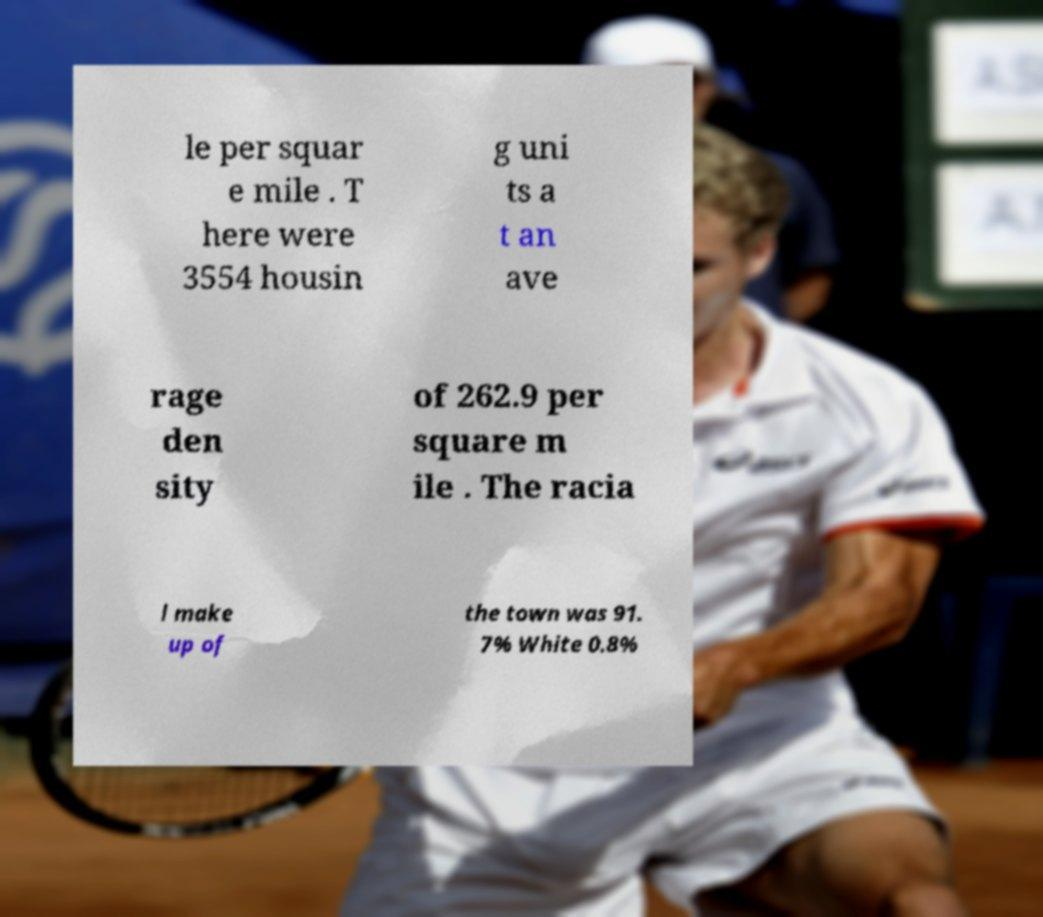For documentation purposes, I need the text within this image transcribed. Could you provide that? le per squar e mile . T here were 3554 housin g uni ts a t an ave rage den sity of 262.9 per square m ile . The racia l make up of the town was 91. 7% White 0.8% 